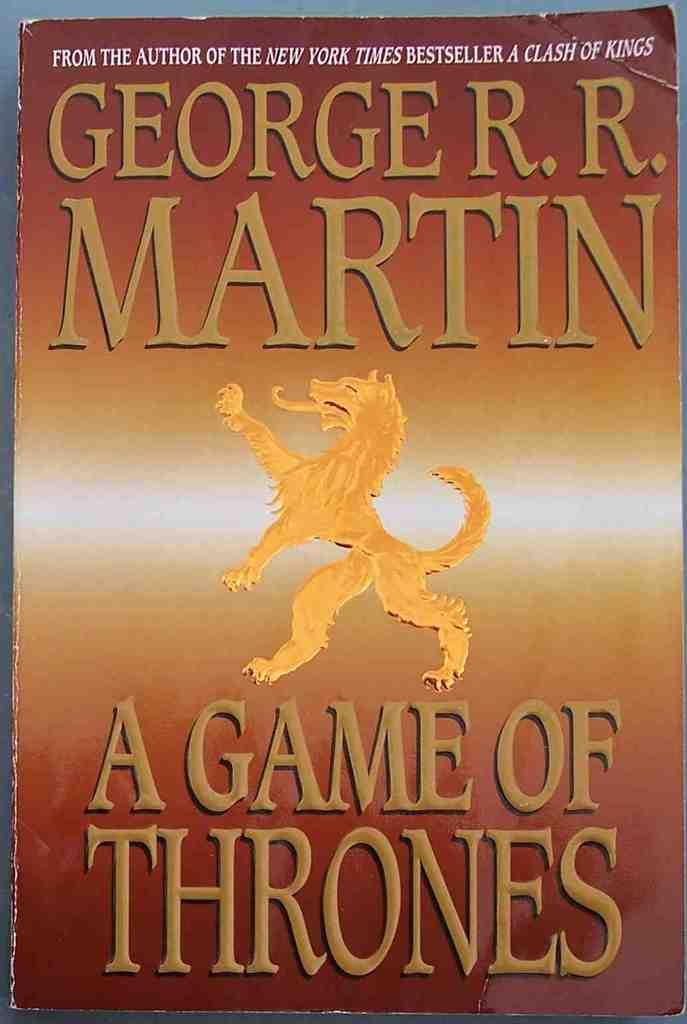<image>
Render a clear and concise summary of the photo. A book by George R.R. Martin has a wolf on the cover. 